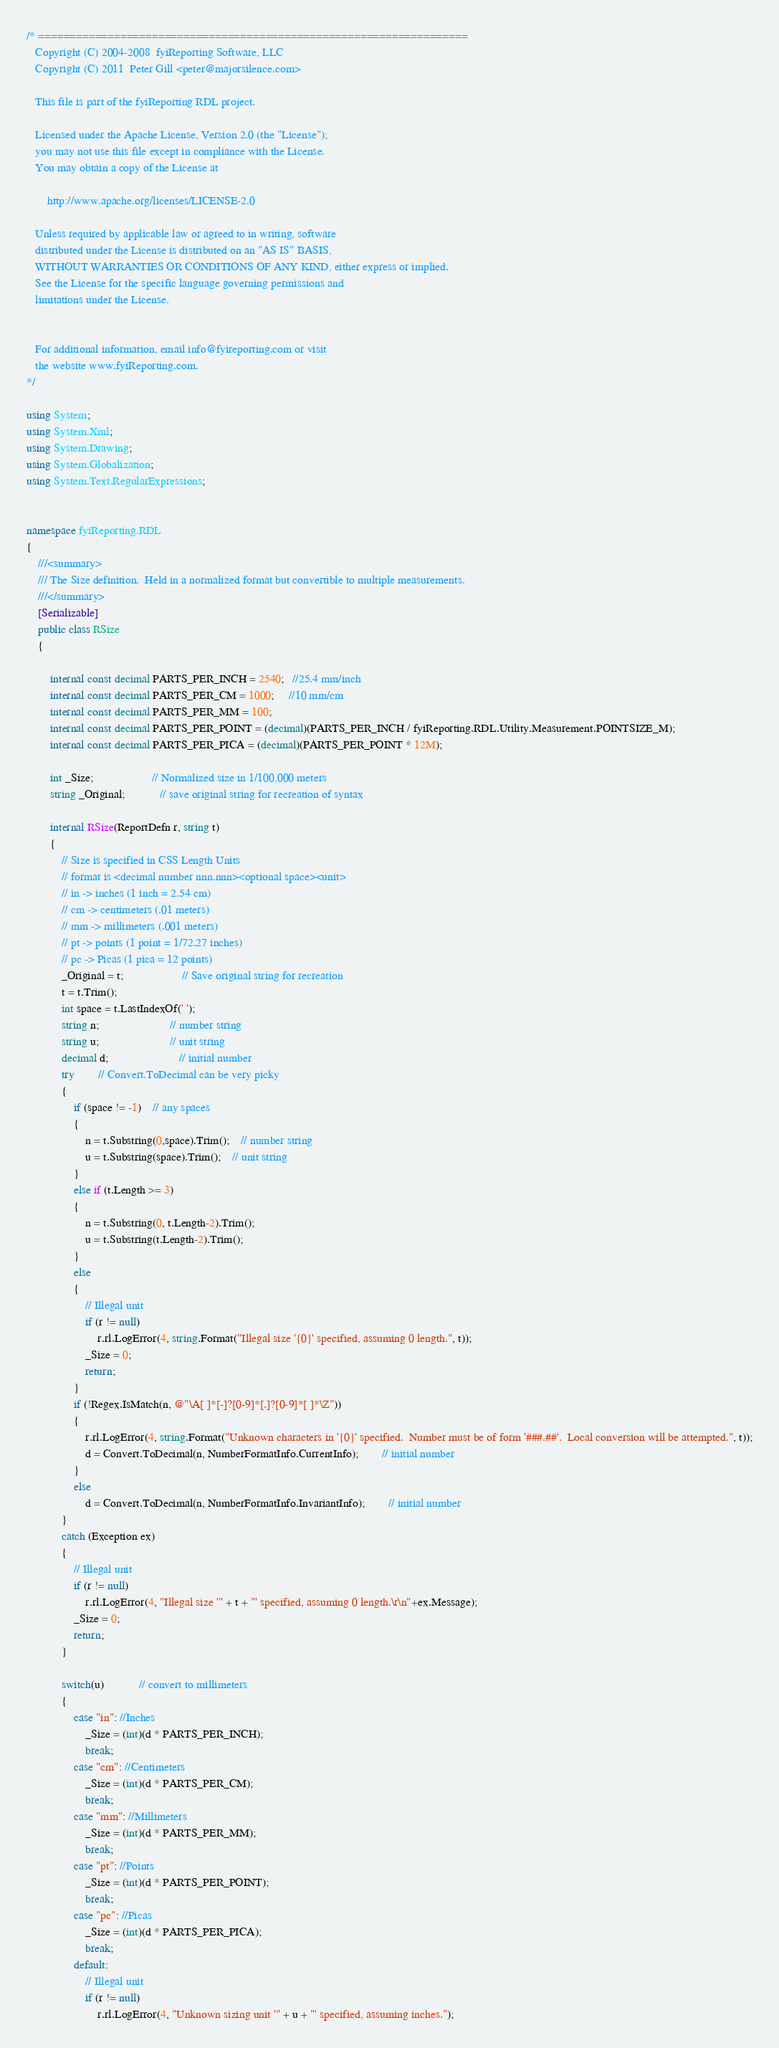<code> <loc_0><loc_0><loc_500><loc_500><_C#_>/* ====================================================================
   Copyright (C) 2004-2008  fyiReporting Software, LLC
   Copyright (C) 2011  Peter Gill <peter@majorsilence.com>

   This file is part of the fyiReporting RDL project.
	
   Licensed under the Apache License, Version 2.0 (the "License");
   you may not use this file except in compliance with the License.
   You may obtain a copy of the License at

       http://www.apache.org/licenses/LICENSE-2.0

   Unless required by applicable law or agreed to in writing, software
   distributed under the License is distributed on an "AS IS" BASIS,
   WITHOUT WARRANTIES OR CONDITIONS OF ANY KIND, either express or implied.
   See the License for the specific language governing permissions and
   limitations under the License.


   For additional information, email info@fyireporting.com or visit
   the website www.fyiReporting.com.
*/

using System;
using System.Xml;
using System.Drawing;
using System.Globalization;
using System.Text.RegularExpressions;


namespace fyiReporting.RDL
{
	///<summary>
	/// The Size definition.  Held in a normalized format but convertible to multiple measurements.
	///</summary>
	[Serializable]
	public class RSize
	{

        internal const decimal PARTS_PER_INCH = 2540;   //25.4 mm/inch
        internal const decimal PARTS_PER_CM = 1000;     //10 mm/cm
        internal const decimal PARTS_PER_MM = 100;
        internal const decimal PARTS_PER_POINT = (decimal)(PARTS_PER_INCH / fyiReporting.RDL.Utility.Measurement.POINTSIZE_M);
        internal const decimal PARTS_PER_PICA = (decimal)(PARTS_PER_POINT * 12M);

		int _Size;					// Normalized size in 1/100,000 meters
		string _Original;			// save original string for recreation of syntax

		internal RSize(ReportDefn r, string t)
		{
			// Size is specified in CSS Length Units
			// format is <decimal number nnn.nnn><optional space><unit>
			// in -> inches (1 inch = 2.54 cm)
			// cm -> centimeters (.01 meters)
			// mm -> millimeters (.001 meters)
			// pt -> points (1 point = 1/72.27 inches)
			// pc -> Picas (1 pica = 12 points)
			_Original = t;					// Save original string for recreation
			t = t.Trim();
			int space = t.LastIndexOf(' '); 
			string n;						// number string
			string u;						// unit string
			decimal d;						// initial number
			try		// Convert.ToDecimal can be very picky
			{
				if (space != -1)	// any spaces
				{
					n = t.Substring(0,space).Trim();	// number string
					u = t.Substring(space).Trim();	// unit string
				}
				else if (t.Length >= 3)
				{
					n = t.Substring(0, t.Length-2).Trim();
					u = t.Substring(t.Length-2).Trim();
				}
				else
				{
					// Illegal unit
                    if (r != null)
					    r.rl.LogError(4, string.Format("Illegal size '{0}' specified, assuming 0 length.", t));
					_Size = 0;
					return;
				}
				if (!Regex.IsMatch(n, @"\A[ ]*[-]?[0-9]*[.]?[0-9]*[ ]*\Z"))
				{
					r.rl.LogError(4, string.Format("Unknown characters in '{0}' specified.  Number must be of form '###.##'.  Local conversion will be attempted.", t));
					d = Convert.ToDecimal(n, NumberFormatInfo.CurrentInfo);		// initial number
				}
				else
					d = Convert.ToDecimal(n, NumberFormatInfo.InvariantInfo);		// initial number
			}
			catch (Exception ex) 
			{
				// Illegal unit
                if (r != null)
				    r.rl.LogError(4, "Illegal size '" + t + "' specified, assuming 0 length.\r\n"+ex.Message);
				_Size = 0;
				return;
			}

			switch(u)			// convert to millimeters
			{
                case "in": //Inches
                    _Size = (int)(d * PARTS_PER_INCH);
                    break;
                case "cm": //Centimeters
                    _Size = (int)(d * PARTS_PER_CM);
                    break;
                case "mm": //Millimeters
                    _Size = (int)(d * PARTS_PER_MM);
                    break;
                case "pt": //Points
                    _Size = (int)(d * PARTS_PER_POINT);
                    break;
                case "pc": //Picas
                    _Size = (int)(d * PARTS_PER_PICA);
                    break;
                default:
                    // Illegal unit
                    if (r != null)
                        r.rl.LogError(4, "Unknown sizing unit '" + u + "' specified, assuming inches.");</code> 